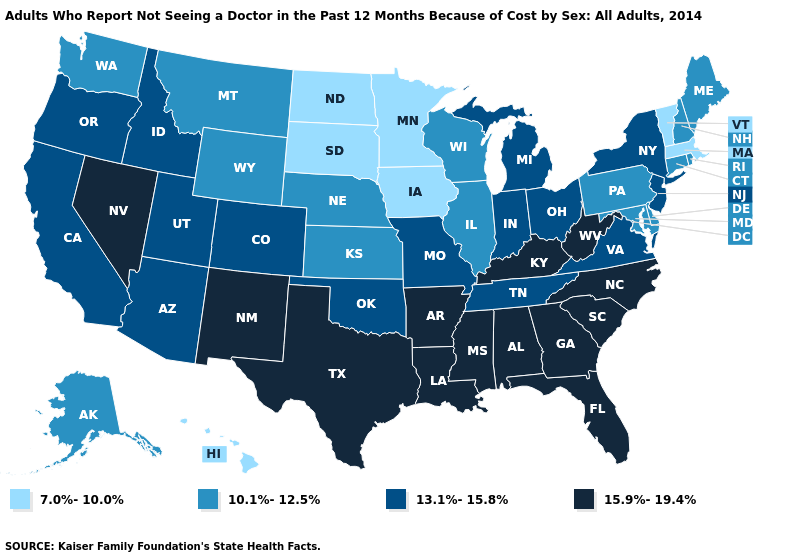Does Kansas have the lowest value in the USA?
Be succinct. No. What is the value of Nebraska?
Give a very brief answer. 10.1%-12.5%. Does Delaware have the highest value in the USA?
Write a very short answer. No. What is the value of Wyoming?
Be succinct. 10.1%-12.5%. Among the states that border Mississippi , which have the lowest value?
Short answer required. Tennessee. Does the first symbol in the legend represent the smallest category?
Be succinct. Yes. Among the states that border New Mexico , which have the lowest value?
Short answer required. Arizona, Colorado, Oklahoma, Utah. Name the states that have a value in the range 10.1%-12.5%?
Keep it brief. Alaska, Connecticut, Delaware, Illinois, Kansas, Maine, Maryland, Montana, Nebraska, New Hampshire, Pennsylvania, Rhode Island, Washington, Wisconsin, Wyoming. Name the states that have a value in the range 10.1%-12.5%?
Keep it brief. Alaska, Connecticut, Delaware, Illinois, Kansas, Maine, Maryland, Montana, Nebraska, New Hampshire, Pennsylvania, Rhode Island, Washington, Wisconsin, Wyoming. Does Arkansas have the highest value in the South?
Answer briefly. Yes. What is the highest value in states that border South Carolina?
Answer briefly. 15.9%-19.4%. Does the map have missing data?
Concise answer only. No. Name the states that have a value in the range 15.9%-19.4%?
Be succinct. Alabama, Arkansas, Florida, Georgia, Kentucky, Louisiana, Mississippi, Nevada, New Mexico, North Carolina, South Carolina, Texas, West Virginia. Which states have the highest value in the USA?
Answer briefly. Alabama, Arkansas, Florida, Georgia, Kentucky, Louisiana, Mississippi, Nevada, New Mexico, North Carolina, South Carolina, Texas, West Virginia. What is the highest value in the USA?
Be succinct. 15.9%-19.4%. 